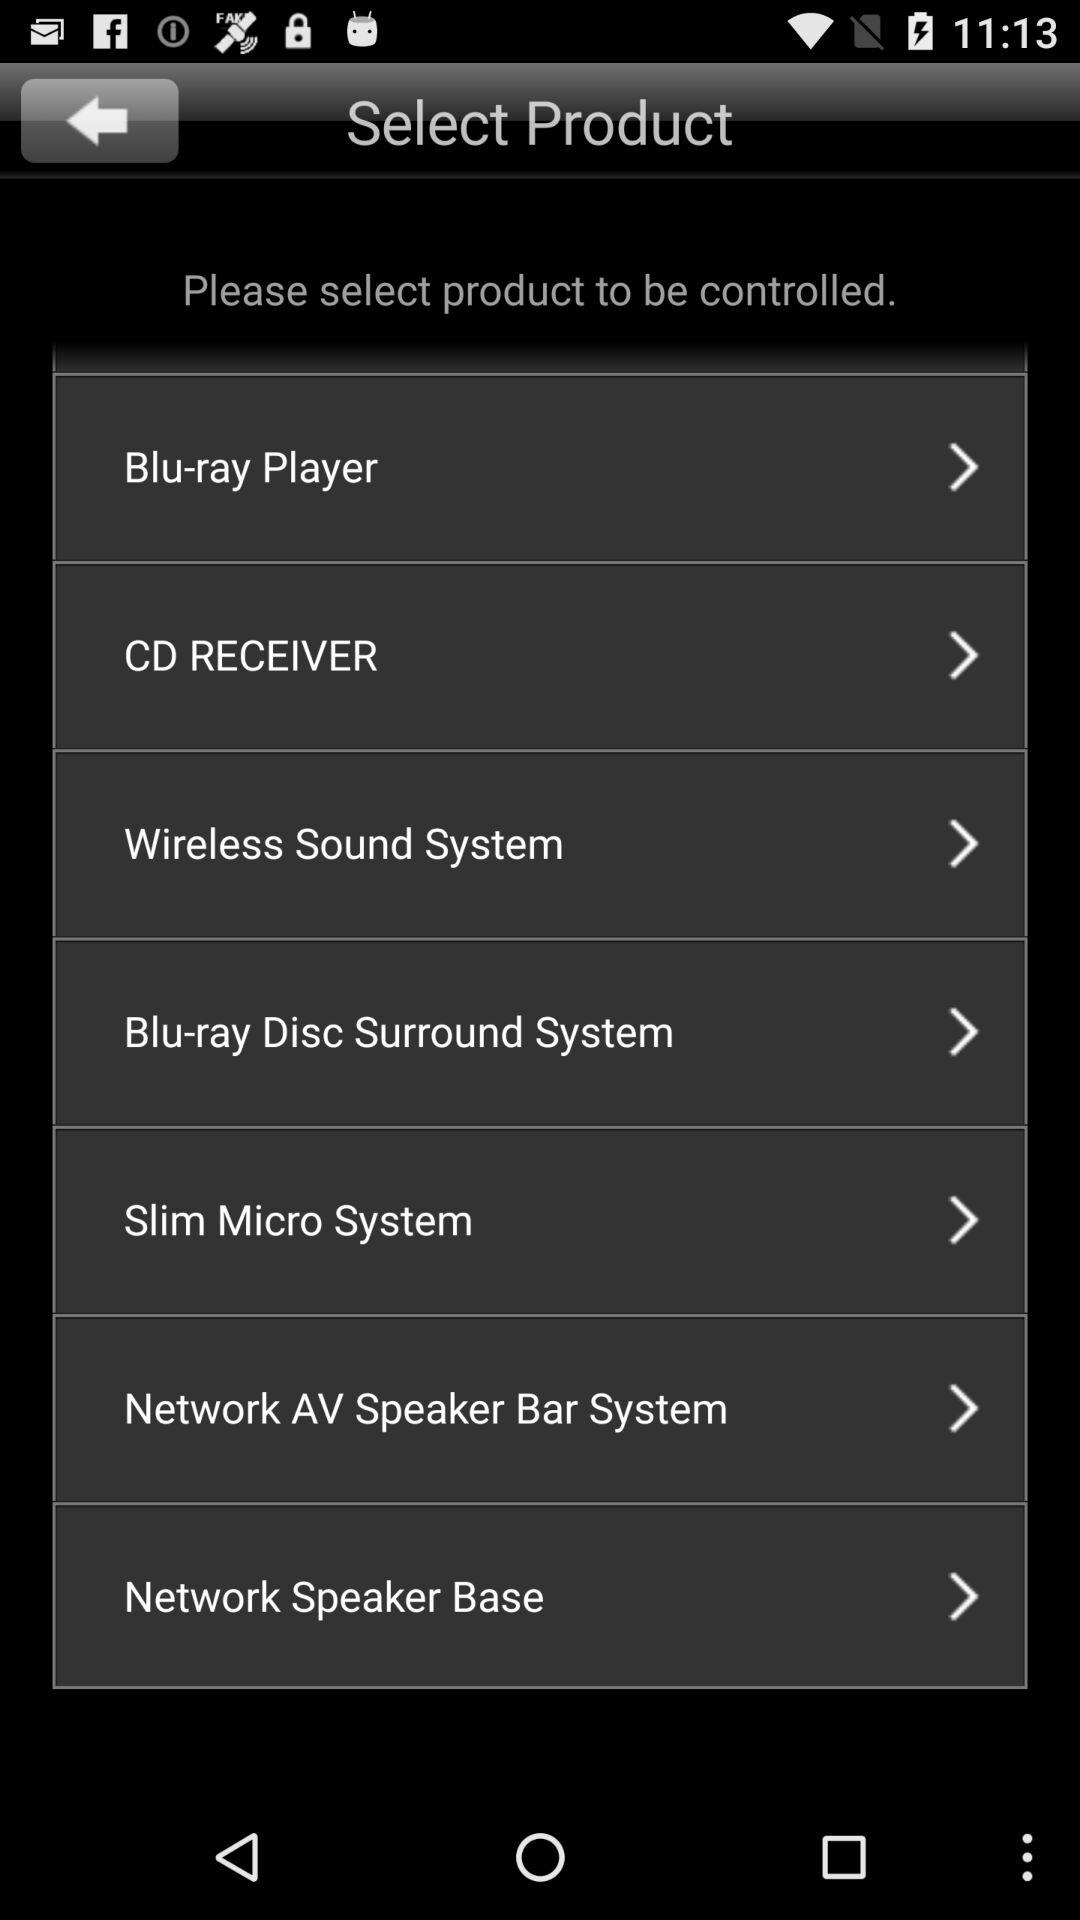What are the names of the different products that need to be controlled? The names of the different products that need to be controlled are "Blu-ray Player", "CD RECEIVER", "Wireless Sound System", "Blu-ray Disc Surround System", "Slim Micro System", "Network AV Speaker Bar System" and "Network Speaker Base". 